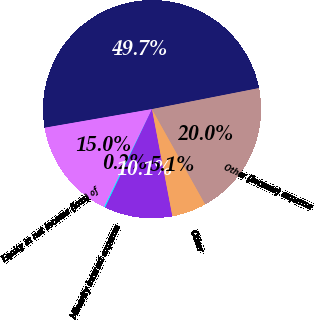Convert chart to OTSL. <chart><loc_0><loc_0><loc_500><loc_500><pie_chart><fcel>OtherIncomeandExpenseItems (in<fcel>Equity in net income (loss) of<fcel>Minority interest expense<fcel>Federal excise and capital<fcel>Other<fcel>Other (income) expense<nl><fcel>49.65%<fcel>15.02%<fcel>0.17%<fcel>10.07%<fcel>5.12%<fcel>19.97%<nl></chart> 